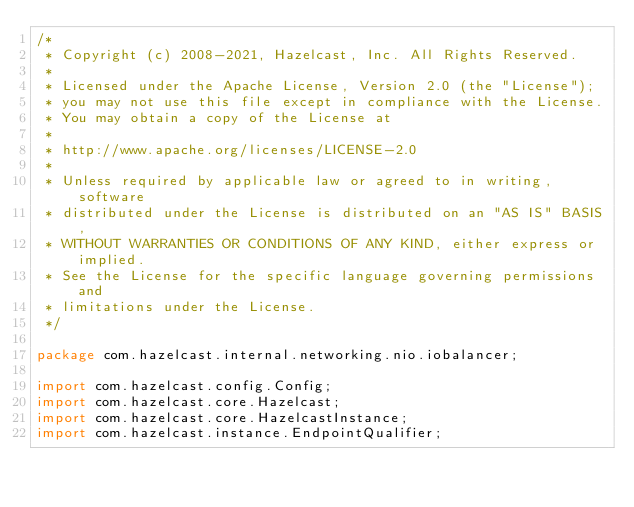Convert code to text. <code><loc_0><loc_0><loc_500><loc_500><_Java_>/*
 * Copyright (c) 2008-2021, Hazelcast, Inc. All Rights Reserved.
 *
 * Licensed under the Apache License, Version 2.0 (the "License");
 * you may not use this file except in compliance with the License.
 * You may obtain a copy of the License at
 *
 * http://www.apache.org/licenses/LICENSE-2.0
 *
 * Unless required by applicable law or agreed to in writing, software
 * distributed under the License is distributed on an "AS IS" BASIS,
 * WITHOUT WARRANTIES OR CONDITIONS OF ANY KIND, either express or implied.
 * See the License for the specific language governing permissions and
 * limitations under the License.
 */

package com.hazelcast.internal.networking.nio.iobalancer;

import com.hazelcast.config.Config;
import com.hazelcast.core.Hazelcast;
import com.hazelcast.core.HazelcastInstance;
import com.hazelcast.instance.EndpointQualifier;</code> 